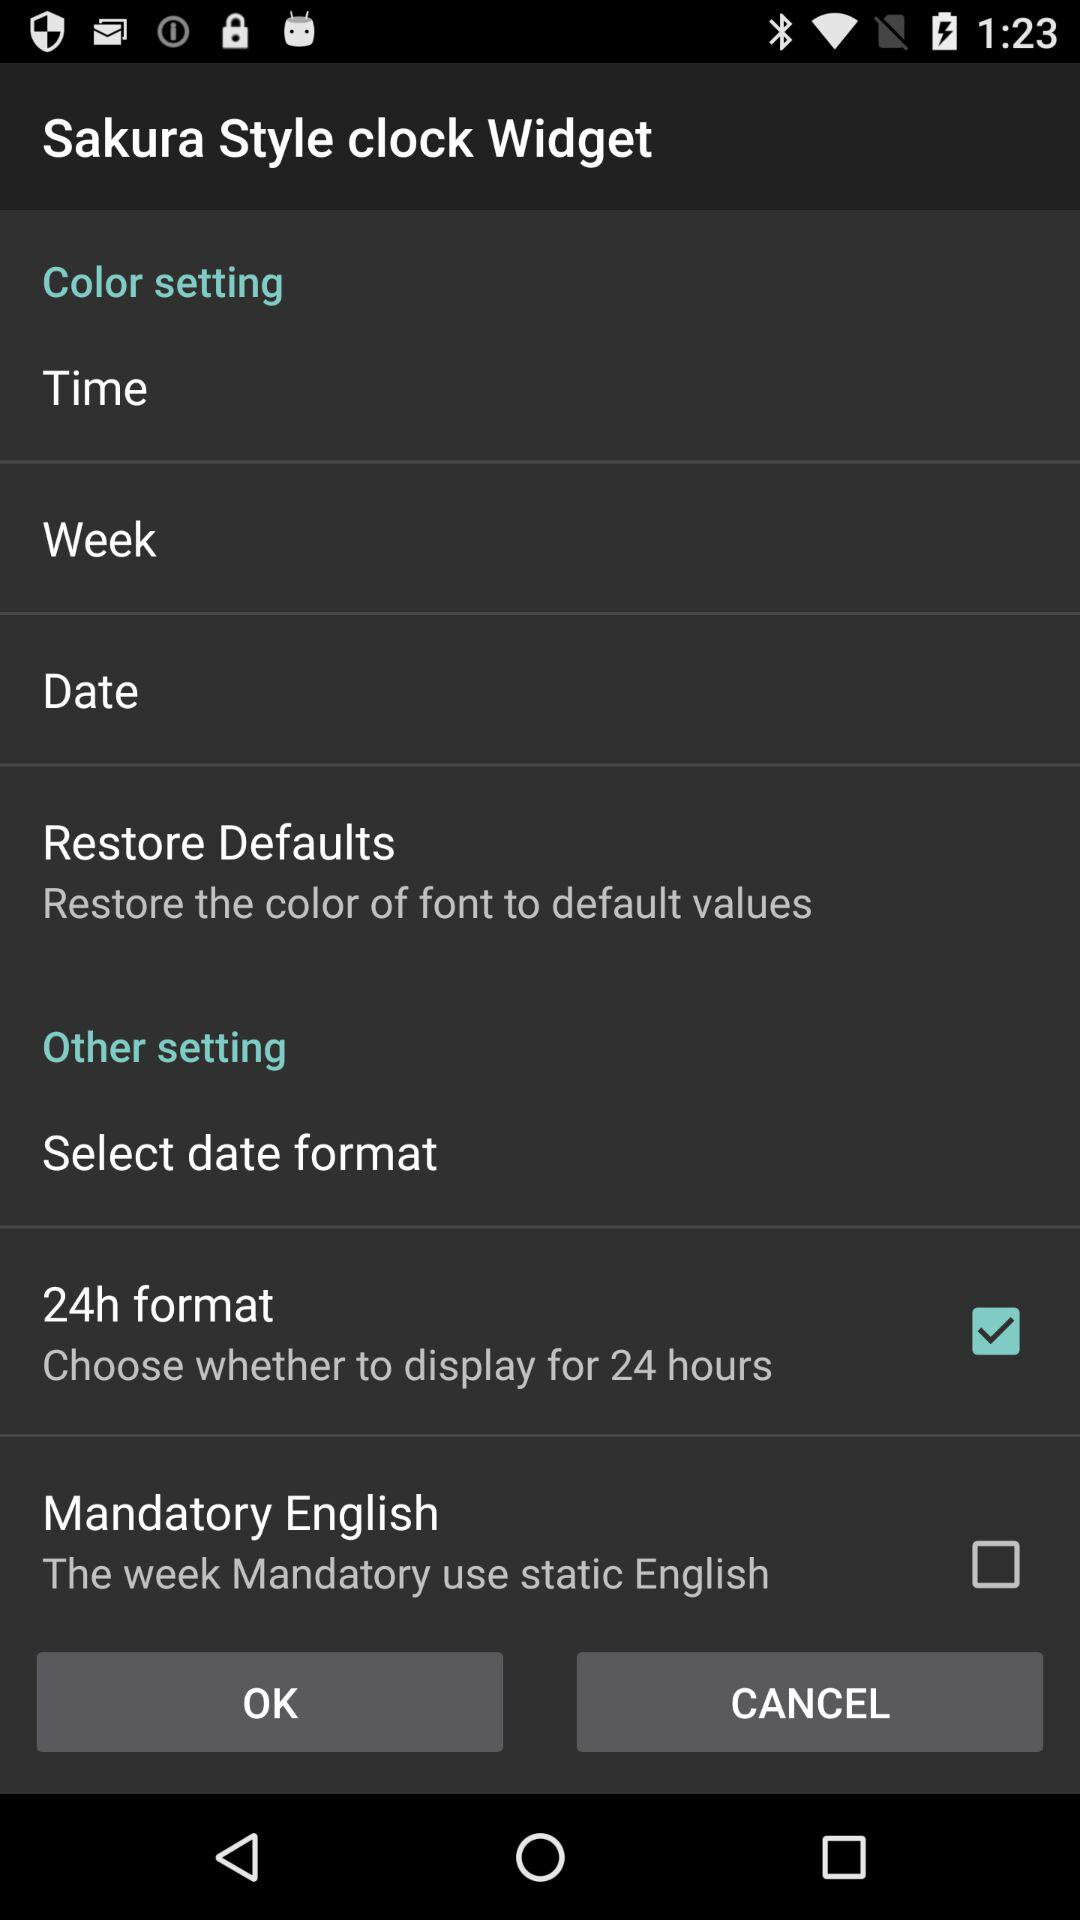What's the status of "Mandatory English"? The status is "off". 